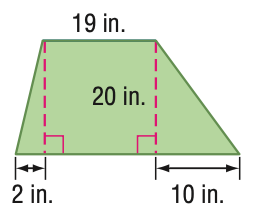Question: Find the area of the figure. Round to the nearest tenth if necessary.
Choices:
A. 92.5
B. 250
C. 500
D. 1000
Answer with the letter. Answer: C 